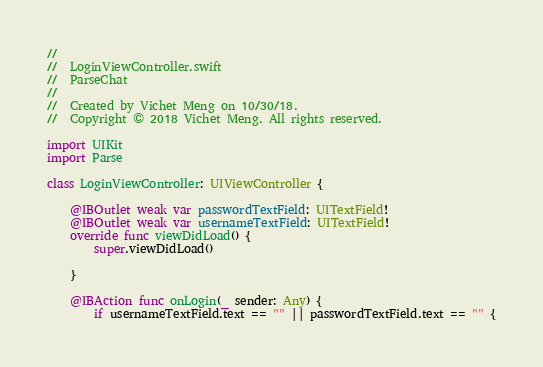Convert code to text. <code><loc_0><loc_0><loc_500><loc_500><_Swift_>//
//  LoginViewController.swift
//  ParseChat
//
//  Created by Vichet Meng on 10/30/18.
//  Copyright © 2018 Vichet Meng. All rights reserved.

import UIKit
import Parse

class LoginViewController: UIViewController {

    @IBOutlet weak var passwordTextField: UITextField!
    @IBOutlet weak var usernameTextField: UITextField!
    override func viewDidLoad() {
        super.viewDidLoad()
        
    }
    
    @IBAction func onLogin(_ sender: Any) {
        if usernameTextField.text == "" || passwordTextField.text == "" {</code> 